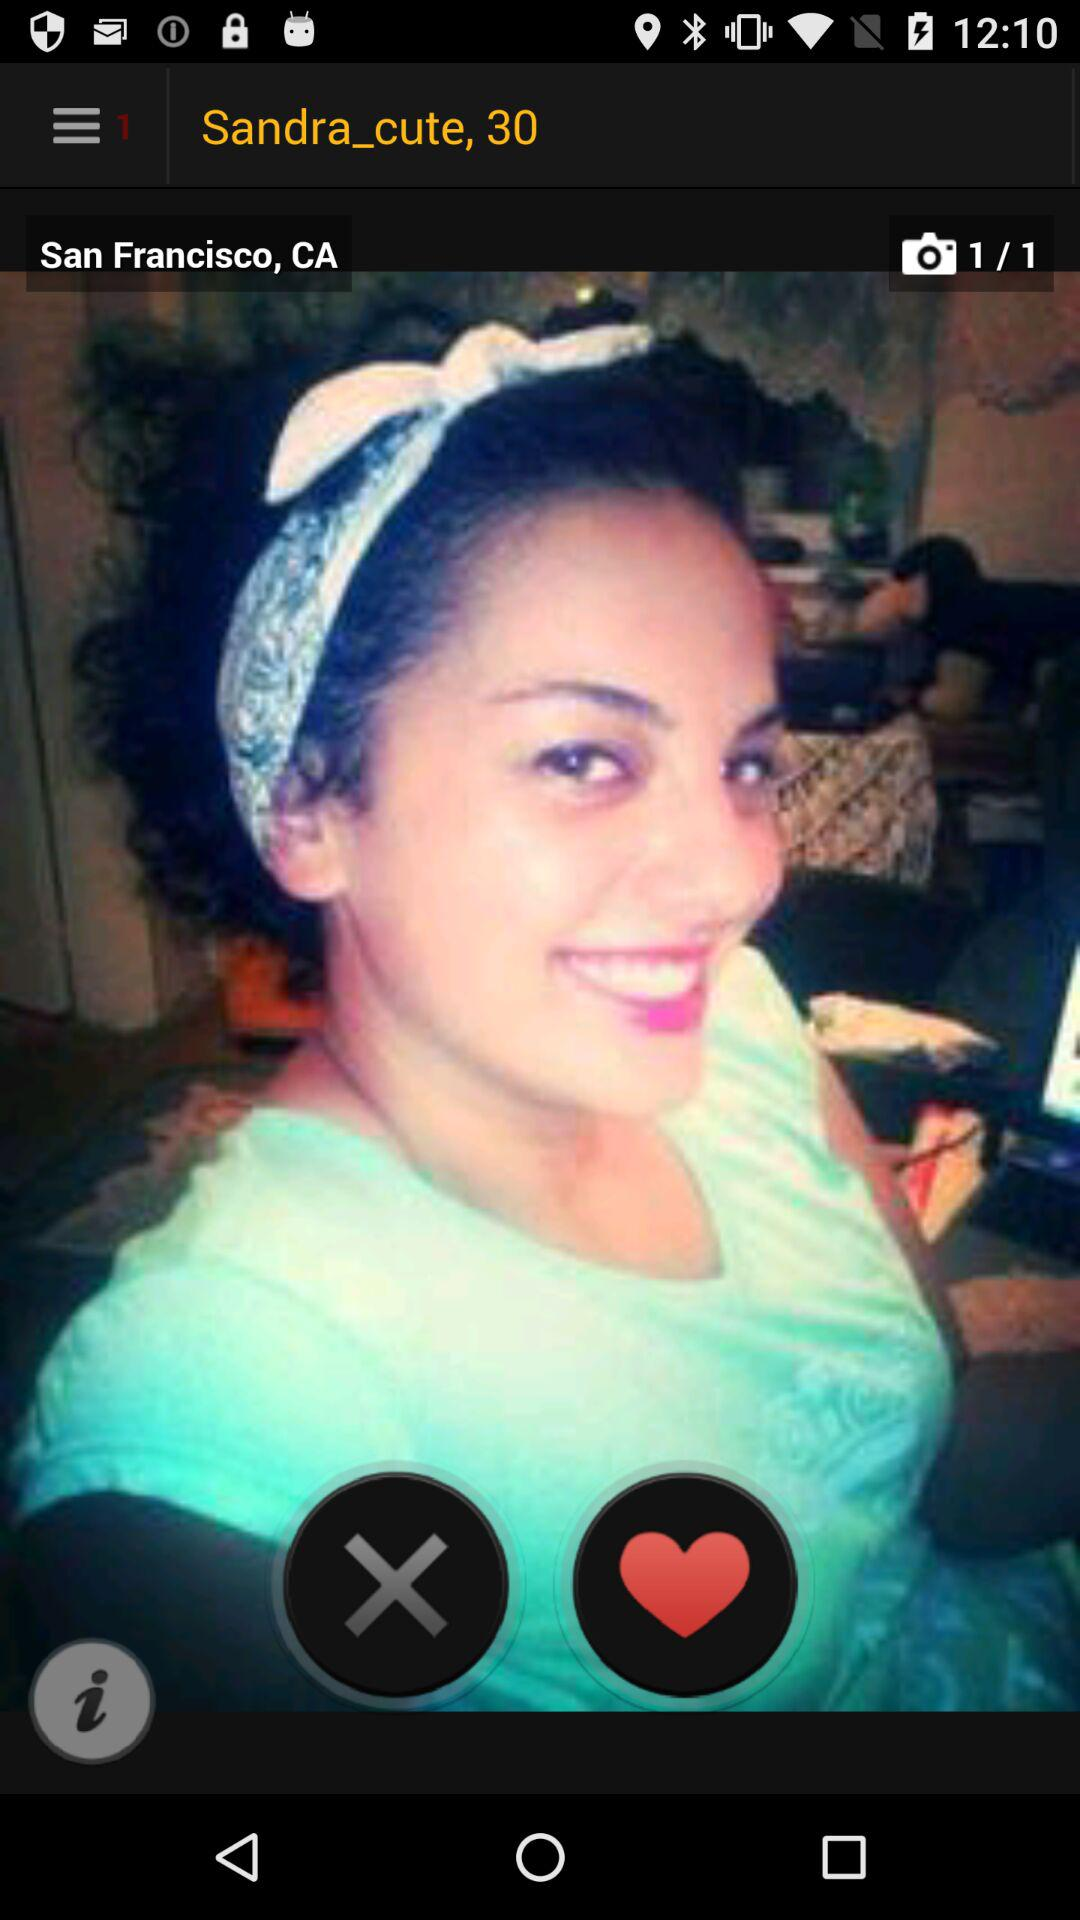What is the age of the user? The age of the user is 30 years old. 